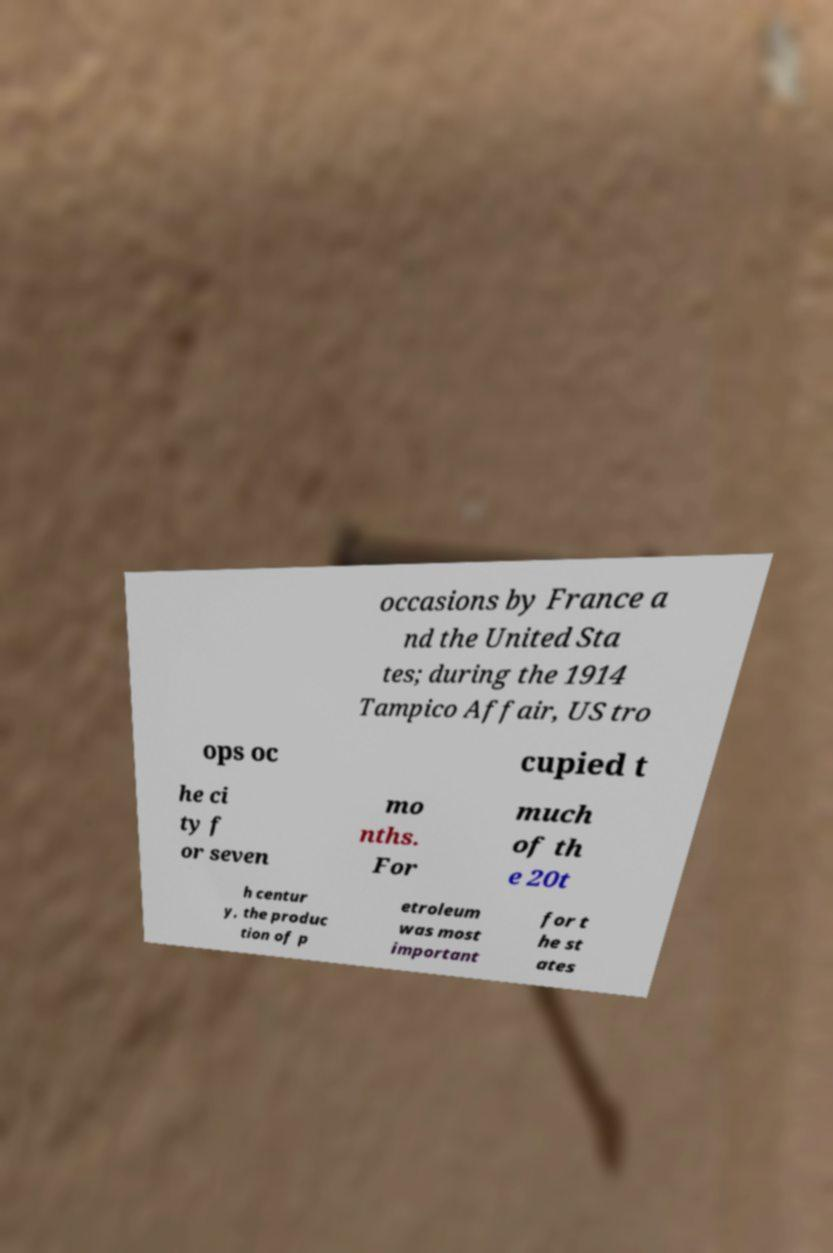Please identify and transcribe the text found in this image. occasions by France a nd the United Sta tes; during the 1914 Tampico Affair, US tro ops oc cupied t he ci ty f or seven mo nths. For much of th e 20t h centur y, the produc tion of p etroleum was most important for t he st ates 